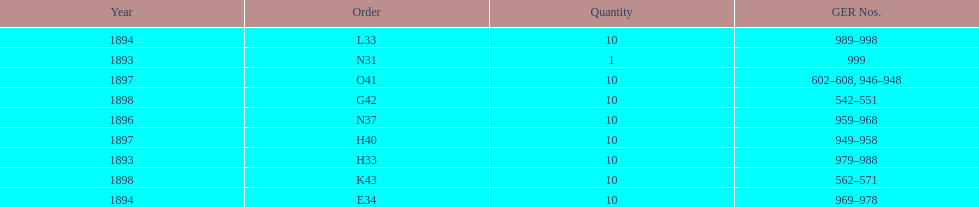Were there more n31 or e34 ordered? E34. 